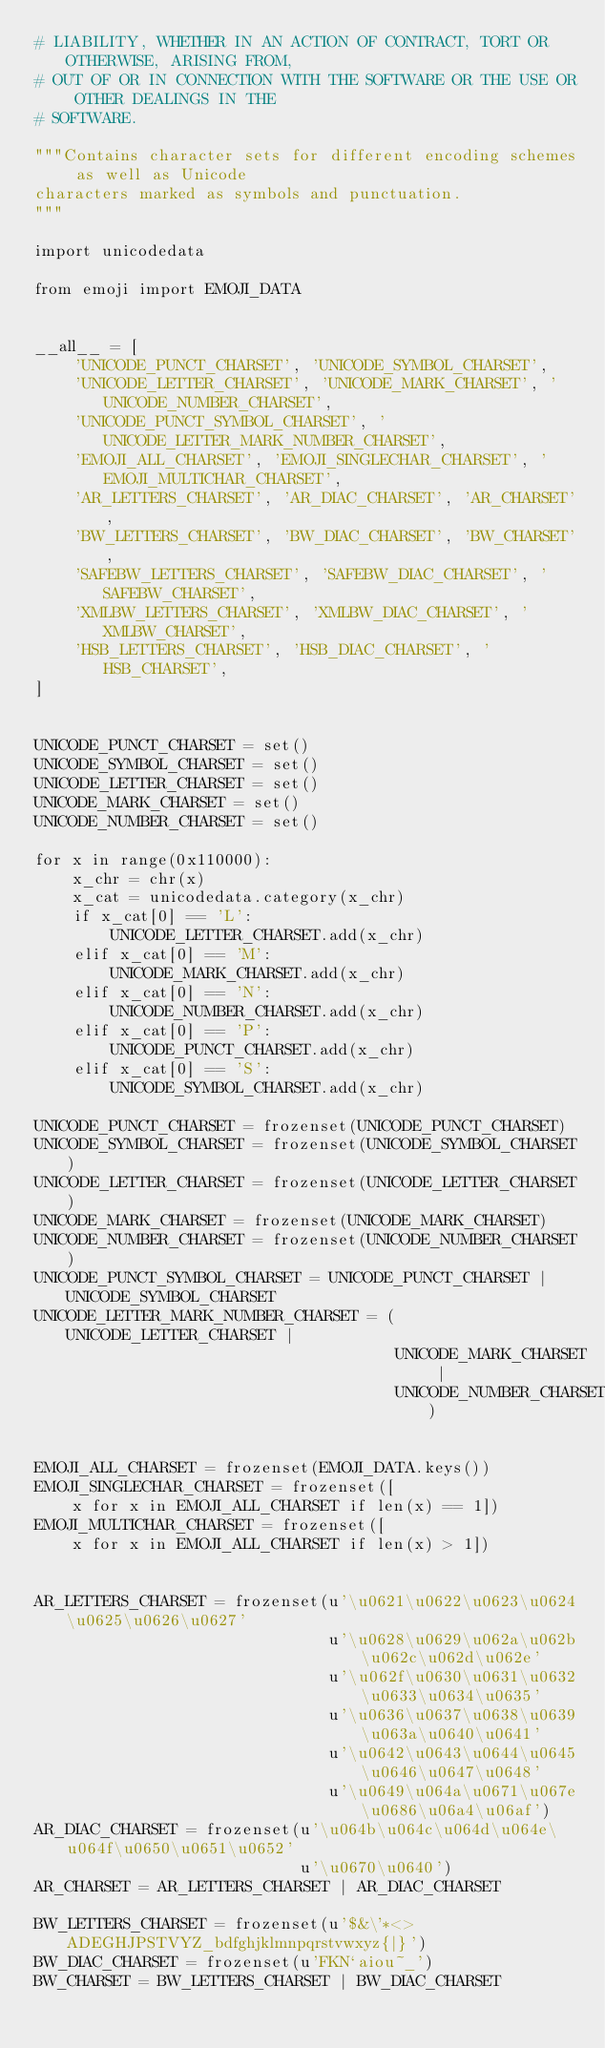Convert code to text. <code><loc_0><loc_0><loc_500><loc_500><_Python_># LIABILITY, WHETHER IN AN ACTION OF CONTRACT, TORT OR OTHERWISE, ARISING FROM,
# OUT OF OR IN CONNECTION WITH THE SOFTWARE OR THE USE OR OTHER DEALINGS IN THE
# SOFTWARE.

"""Contains character sets for different encoding schemes as well as Unicode
characters marked as symbols and punctuation.
"""

import unicodedata

from emoji import EMOJI_DATA


__all__ = [
    'UNICODE_PUNCT_CHARSET', 'UNICODE_SYMBOL_CHARSET',
    'UNICODE_LETTER_CHARSET', 'UNICODE_MARK_CHARSET', 'UNICODE_NUMBER_CHARSET',
    'UNICODE_PUNCT_SYMBOL_CHARSET', 'UNICODE_LETTER_MARK_NUMBER_CHARSET',
    'EMOJI_ALL_CHARSET', 'EMOJI_SINGLECHAR_CHARSET', 'EMOJI_MULTICHAR_CHARSET', 
    'AR_LETTERS_CHARSET', 'AR_DIAC_CHARSET', 'AR_CHARSET',
    'BW_LETTERS_CHARSET', 'BW_DIAC_CHARSET', 'BW_CHARSET',
    'SAFEBW_LETTERS_CHARSET', 'SAFEBW_DIAC_CHARSET', 'SAFEBW_CHARSET',
    'XMLBW_LETTERS_CHARSET', 'XMLBW_DIAC_CHARSET', 'XMLBW_CHARSET',
    'HSB_LETTERS_CHARSET', 'HSB_DIAC_CHARSET', 'HSB_CHARSET',
]


UNICODE_PUNCT_CHARSET = set()
UNICODE_SYMBOL_CHARSET = set()
UNICODE_LETTER_CHARSET = set()
UNICODE_MARK_CHARSET = set()
UNICODE_NUMBER_CHARSET = set()

for x in range(0x110000):
    x_chr = chr(x)
    x_cat = unicodedata.category(x_chr)
    if x_cat[0] == 'L':
        UNICODE_LETTER_CHARSET.add(x_chr)
    elif x_cat[0] == 'M':
        UNICODE_MARK_CHARSET.add(x_chr)
    elif x_cat[0] == 'N':
        UNICODE_NUMBER_CHARSET.add(x_chr)
    elif x_cat[0] == 'P':
        UNICODE_PUNCT_CHARSET.add(x_chr)
    elif x_cat[0] == 'S':
        UNICODE_SYMBOL_CHARSET.add(x_chr)

UNICODE_PUNCT_CHARSET = frozenset(UNICODE_PUNCT_CHARSET)
UNICODE_SYMBOL_CHARSET = frozenset(UNICODE_SYMBOL_CHARSET)
UNICODE_LETTER_CHARSET = frozenset(UNICODE_LETTER_CHARSET)
UNICODE_MARK_CHARSET = frozenset(UNICODE_MARK_CHARSET)
UNICODE_NUMBER_CHARSET = frozenset(UNICODE_NUMBER_CHARSET)
UNICODE_PUNCT_SYMBOL_CHARSET = UNICODE_PUNCT_CHARSET | UNICODE_SYMBOL_CHARSET
UNICODE_LETTER_MARK_NUMBER_CHARSET = (UNICODE_LETTER_CHARSET |
                                      UNICODE_MARK_CHARSET |
                                      UNICODE_NUMBER_CHARSET)


EMOJI_ALL_CHARSET = frozenset(EMOJI_DATA.keys())
EMOJI_SINGLECHAR_CHARSET = frozenset([
    x for x in EMOJI_ALL_CHARSET if len(x) == 1])
EMOJI_MULTICHAR_CHARSET = frozenset([
    x for x in EMOJI_ALL_CHARSET if len(x) > 1])


AR_LETTERS_CHARSET = frozenset(u'\u0621\u0622\u0623\u0624\u0625\u0626\u0627'
                               u'\u0628\u0629\u062a\u062b\u062c\u062d\u062e'
                               u'\u062f\u0630\u0631\u0632\u0633\u0634\u0635'
                               u'\u0636\u0637\u0638\u0639\u063a\u0640\u0641'
                               u'\u0642\u0643\u0644\u0645\u0646\u0647\u0648'
                               u'\u0649\u064a\u0671\u067e\u0686\u06a4\u06af')
AR_DIAC_CHARSET = frozenset(u'\u064b\u064c\u064d\u064e\u064f\u0650\u0651\u0652'
                            u'\u0670\u0640')
AR_CHARSET = AR_LETTERS_CHARSET | AR_DIAC_CHARSET

BW_LETTERS_CHARSET = frozenset(u'$&\'*<>ADEGHJPSTVYZ_bdfghjklmnpqrstvwxyz{|}')
BW_DIAC_CHARSET = frozenset(u'FKN`aiou~_')
BW_CHARSET = BW_LETTERS_CHARSET | BW_DIAC_CHARSET
</code> 